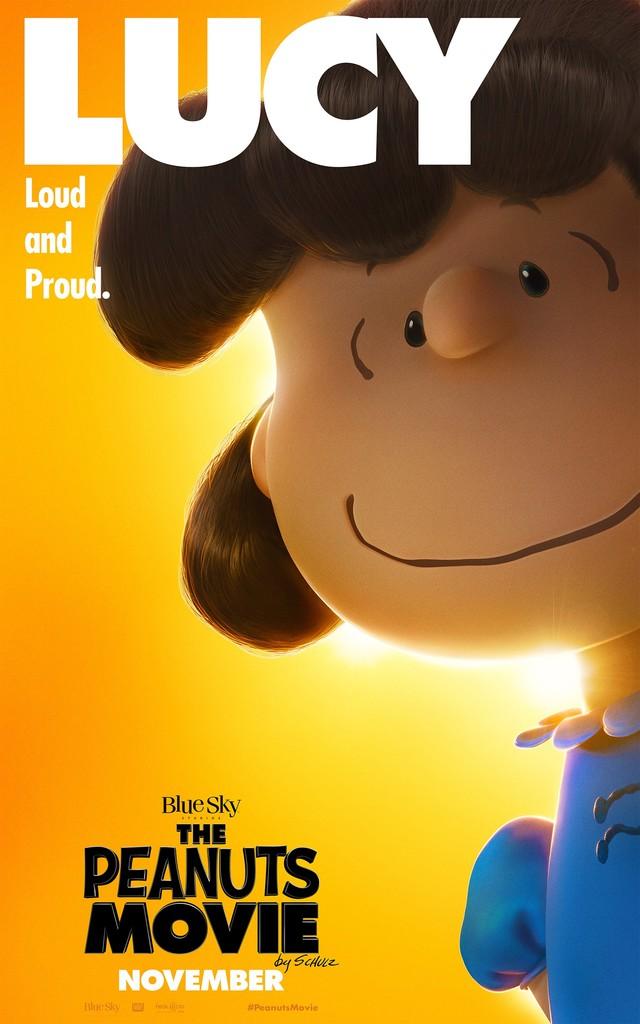Which character is featured on this poster?
Ensure brevity in your answer.  Lucy. What is the name of this movie?
Provide a succinct answer. The peanuts movie. 